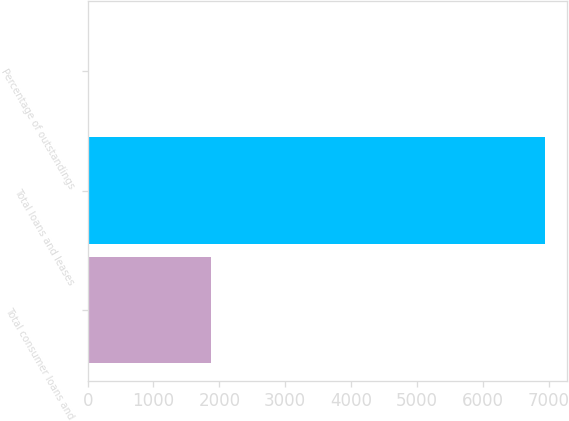Convert chart to OTSL. <chart><loc_0><loc_0><loc_500><loc_500><bar_chart><fcel>Total consumer loans and<fcel>Total loans and leases<fcel>Percentage of outstandings<nl><fcel>1871<fcel>6938<fcel>0.77<nl></chart> 